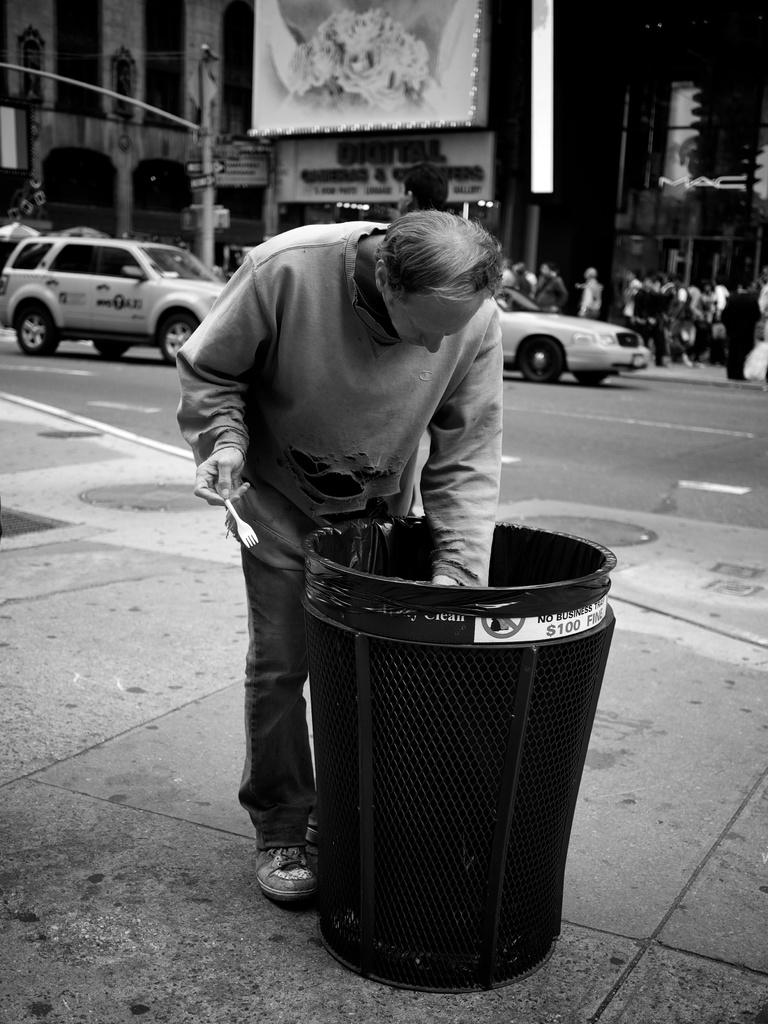<image>
Create a compact narrative representing the image presented. Man digging in the grabage can which has a label saying $100 Fine. 